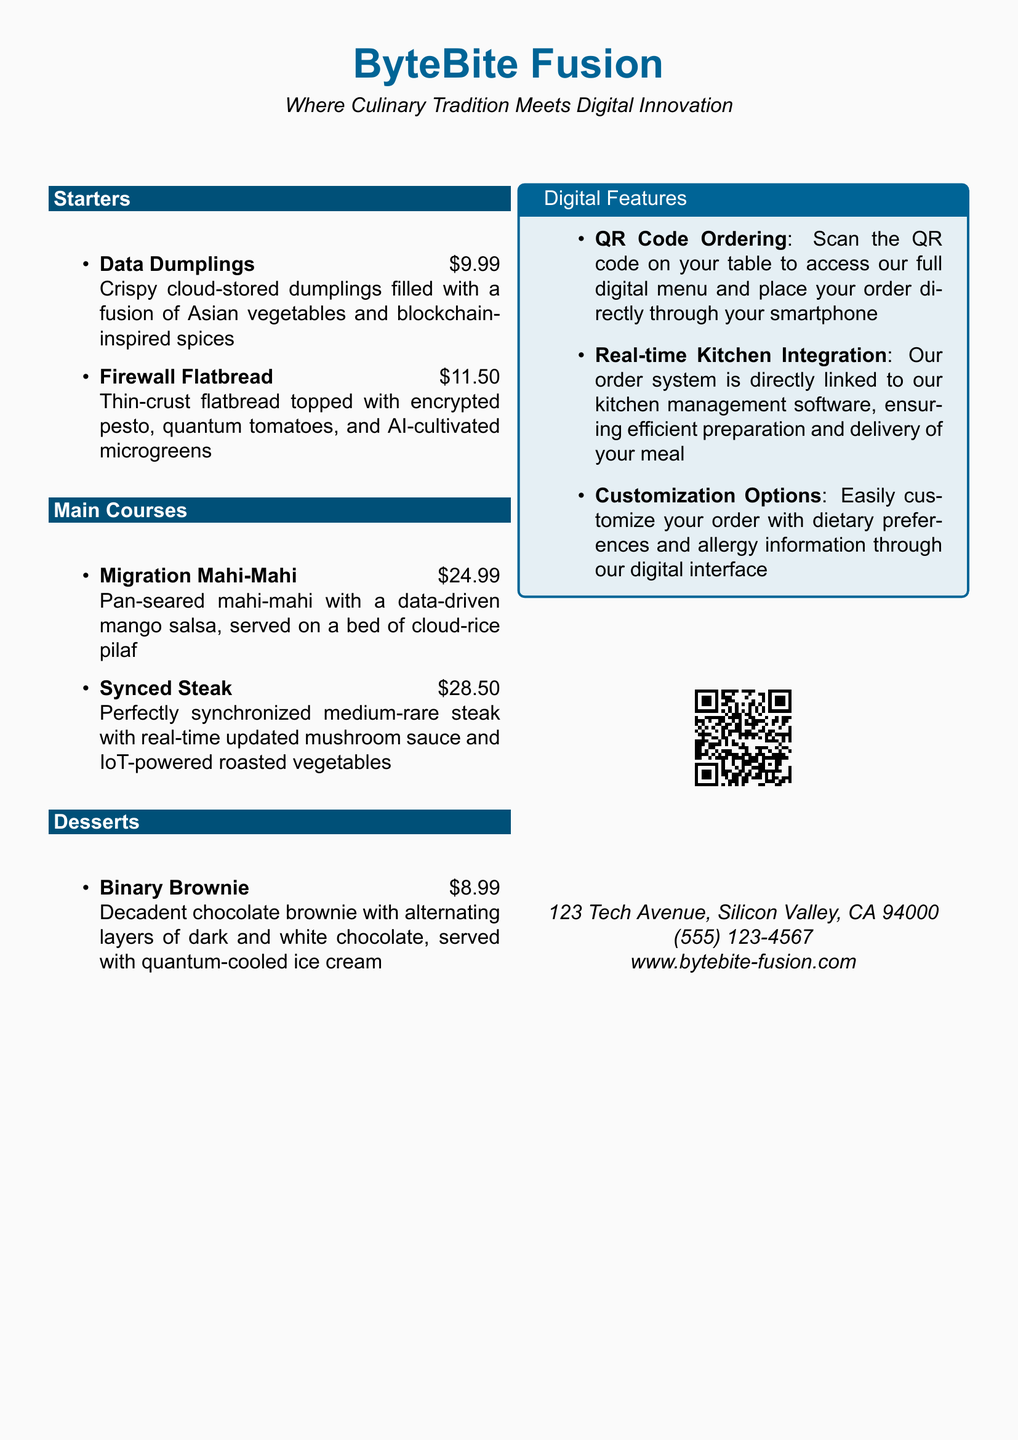What is the name of the restaurant? The restaurant is named "ByteBite Fusion," as stated in the document.
Answer: ByteBite Fusion What is the price of Firewall Flatbread? The document specifies that Firewall Flatbread is priced at $11.50.
Answer: $11.50 How many main course items are listed? The document includes two main course items, which requires counting the list under the Main Courses section.
Answer: 2 What type of dessert is offered? Binary Brownie is the only dessert mentioned in the document.
Answer: Binary Brownie What is the function of the QR code? The document explains that the QR code allows customers to access the digital menu and place orders.
Answer: Access digital menu What kitchen management feature is highlighted? The document states that the order system is linked to the kitchen management software for efficient meal preparation and delivery.
Answer: Real-time Kitchen Integration What are the customization options available? Customers can customize their order with dietary preferences and allergy information through the digital interface.
Answer: Dietary preferences Where is the restaurant located? The document provides the address at the end, which states the location of the restaurant.
Answer: 123 Tech Avenue, Silicon Valley, CA 94000 What is the price of Migration Mahi-Mahi? According to the document, Migration Mahi-Mahi is priced at $24.99.
Answer: $24.99 